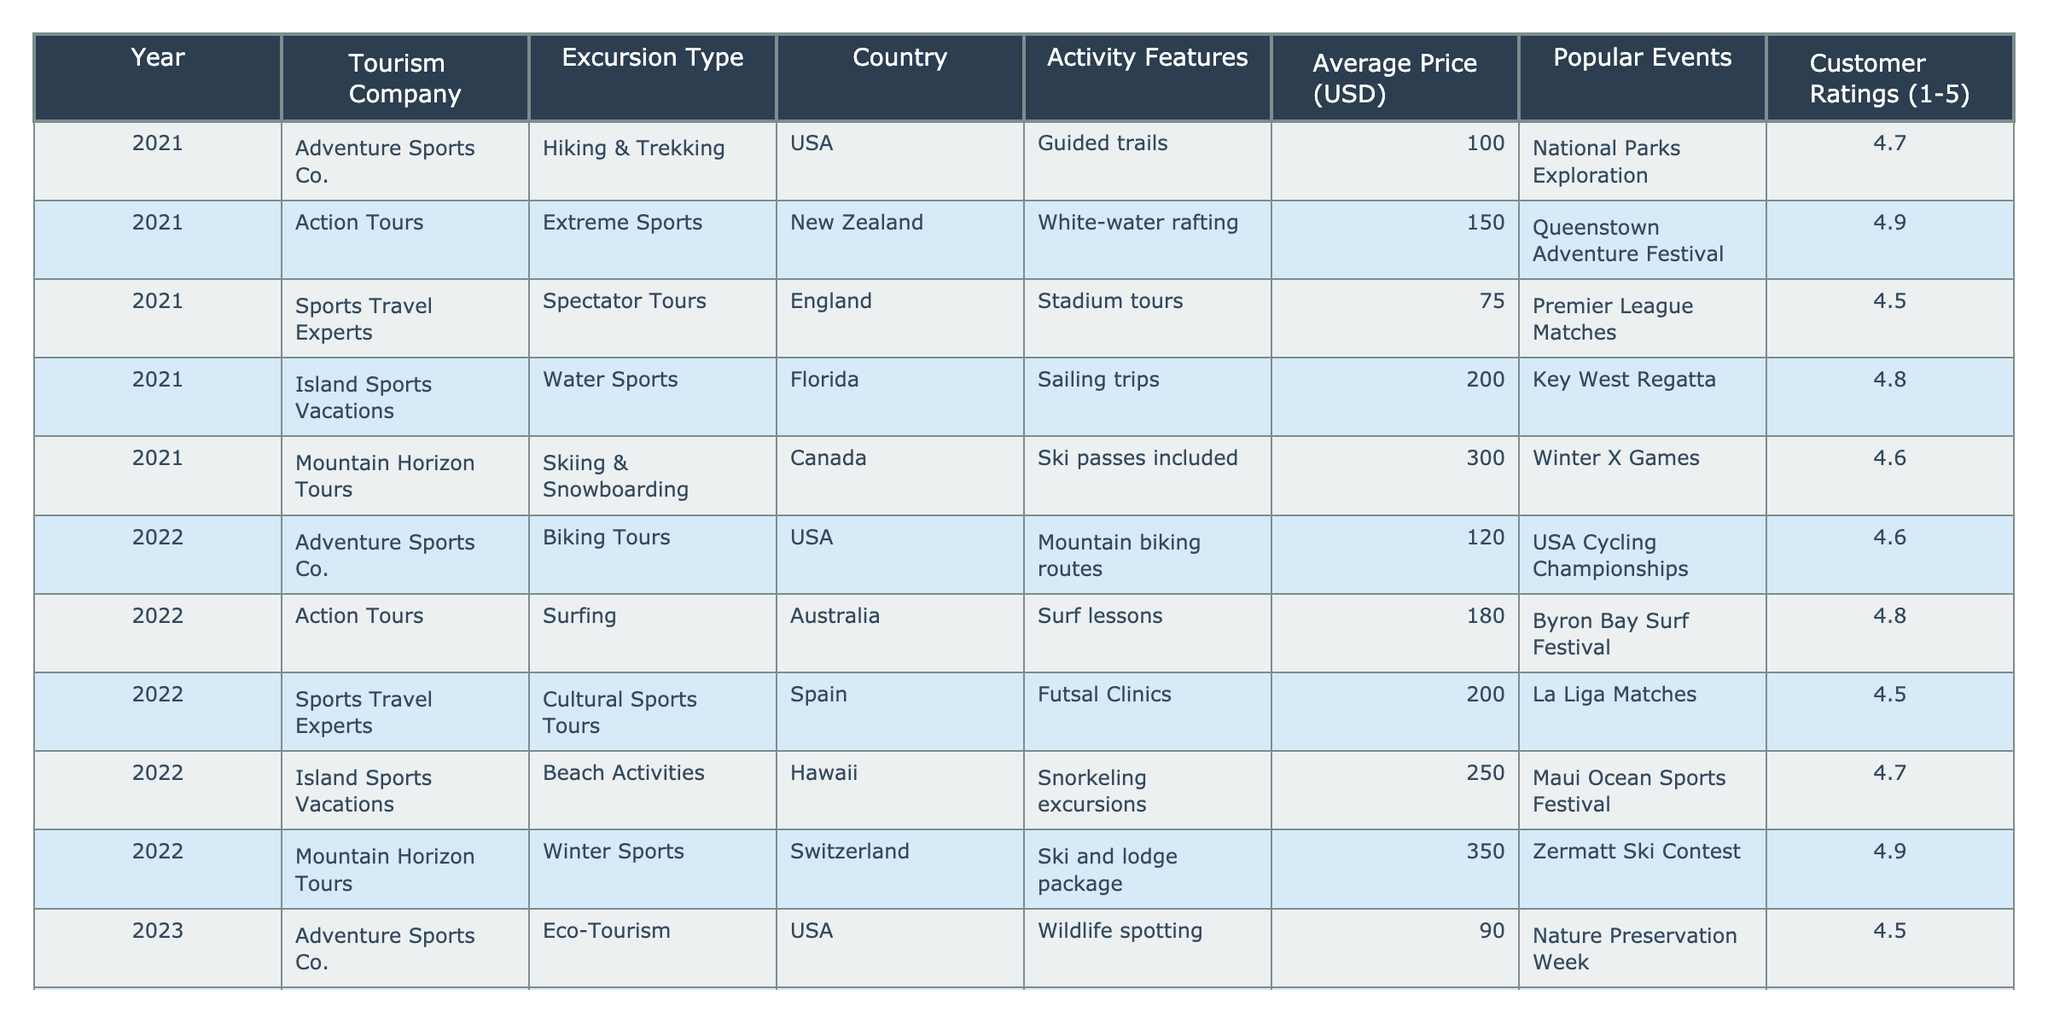What type of excursion did Adventure Sports Co. offer in 2022? Adventure Sports Co. provided Biking Tours in 2022 as indicated in the table under the 'Excursion Type' column.
Answer: Biking Tours Which country is associated with the Island Sports Vacations for Beach Activities in 2022? The table shows that Island Sports Vacations offered Beach Activities in Hawaii in 2022.
Answer: Hawaii What is the average price of excursions offered by Action Tours from 2021 to 2023? The average price can be calculated by adding the prices: (150 + 180 + 220) = 550, then dividing by 3, which gives 550 / 3 = approximately 183.33.
Answer: 183.33 Which excursion had the highest customer rating in 2023? Looking at the 'Customer Ratings' column for 2023, Mountain Horizon Tours' Mixed-Activity Packages had the highest rating of 4.8.
Answer: 4.8 Did Sports Travel Experts offer any excursions in Spain? Yes, according to the table, Sports Travel Experts offered Cultural Sports Tours in Spain in 2022.
Answer: Yes How many countries were represented in the excursions for 2021? By counting the unique countries listed in the 'Country' column for 2021, we have USA, New Zealand, England, Florida, and Canada—totaling 5 countries.
Answer: 5 What was the price difference between the lowest and highest average prices of excursions across all years? The lowest average price was 75 (Spectator Tours in 2021) and the highest was 400 (Mixed-Activity Packages in 2023), the difference is 400 - 75 = 325.
Answer: 325 Was the Adventure Sports Co. excursion in 2023 cheaper than the one in 2021? In 2021, Adventure Sports Co. offered Hiking & Trekking for 100 USD, while in 2023 they offered Eco-Tourism for 90 USD, which is indeed cheaper.
Answer: Yes In which year did Mountain Horizon Tours offer skiing and snowboarding activities? The table shows Mountain Horizon Tours offering Skiing & Snowboarding in Canada in 2021 and also providing Winter Sports in 2022 in Switzerland; thus, the years are 2021 and 2022.
Answer: 2021 and 2022 What notable event was associated with the Extreme Sports offered by Action Tours in New Zealand in 2021? The notable event for the Extreme Sports in 2021 was the Queenstown Adventure Festival, as shown in the table.
Answer: Queenstown Adventure Festival 